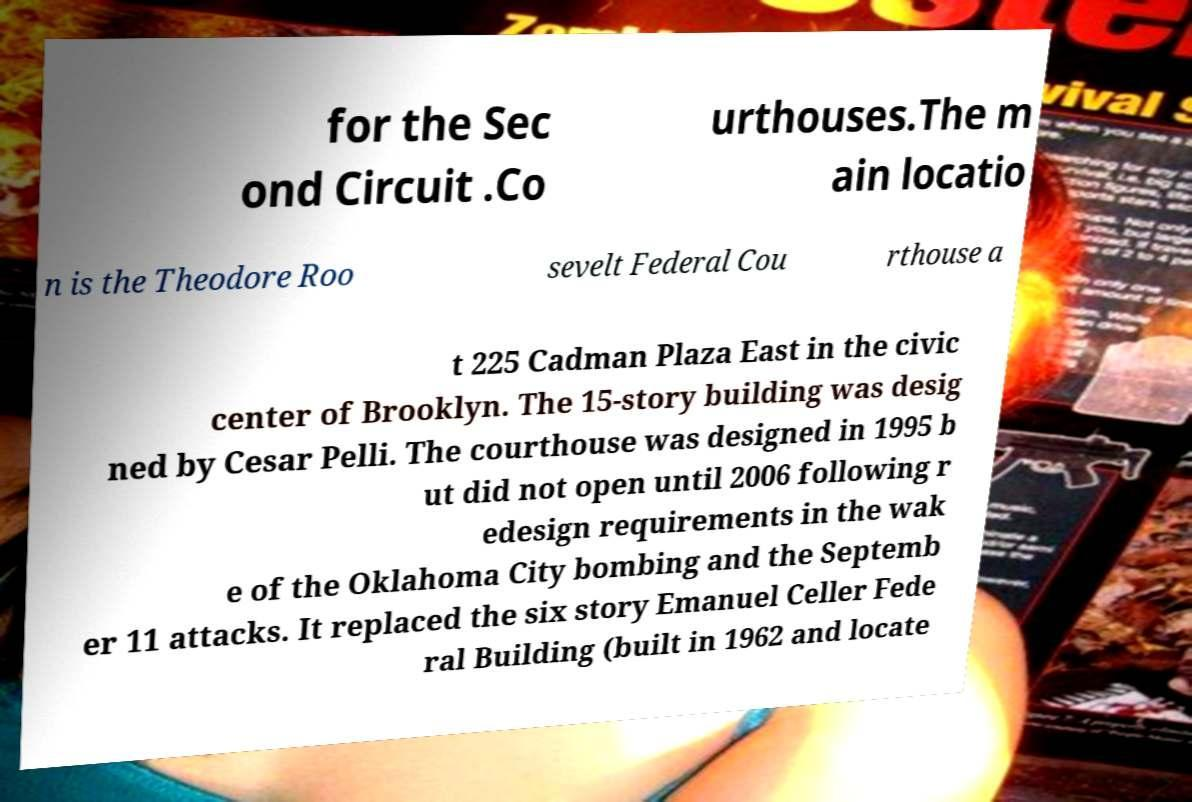Could you assist in decoding the text presented in this image and type it out clearly? for the Sec ond Circuit .Co urthouses.The m ain locatio n is the Theodore Roo sevelt Federal Cou rthouse a t 225 Cadman Plaza East in the civic center of Brooklyn. The 15-story building was desig ned by Cesar Pelli. The courthouse was designed in 1995 b ut did not open until 2006 following r edesign requirements in the wak e of the Oklahoma City bombing and the Septemb er 11 attacks. It replaced the six story Emanuel Celler Fede ral Building (built in 1962 and locate 